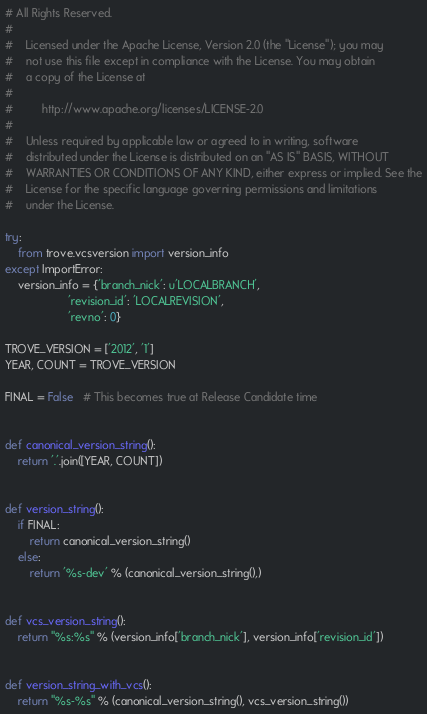Convert code to text. <code><loc_0><loc_0><loc_500><loc_500><_Python_># All Rights Reserved.
#
#    Licensed under the Apache License, Version 2.0 (the "License"); you may
#    not use this file except in compliance with the License. You may obtain
#    a copy of the License at
#
#         http://www.apache.org/licenses/LICENSE-2.0
#
#    Unless required by applicable law or agreed to in writing, software
#    distributed under the License is distributed on an "AS IS" BASIS, WITHOUT
#    WARRANTIES OR CONDITIONS OF ANY KIND, either express or implied. See the
#    License for the specific language governing permissions and limitations
#    under the License.

try:
    from trove.vcsversion import version_info
except ImportError:
    version_info = {'branch_nick': u'LOCALBRANCH',
                    'revision_id': 'LOCALREVISION',
                    'revno': 0}

TROVE_VERSION = ['2012', '1']
YEAR, COUNT = TROVE_VERSION

FINAL = False   # This becomes true at Release Candidate time


def canonical_version_string():
    return '.'.join([YEAR, COUNT])


def version_string():
    if FINAL:
        return canonical_version_string()
    else:
        return '%s-dev' % (canonical_version_string(),)


def vcs_version_string():
    return "%s:%s" % (version_info['branch_nick'], version_info['revision_id'])


def version_string_with_vcs():
    return "%s-%s" % (canonical_version_string(), vcs_version_string())
</code> 